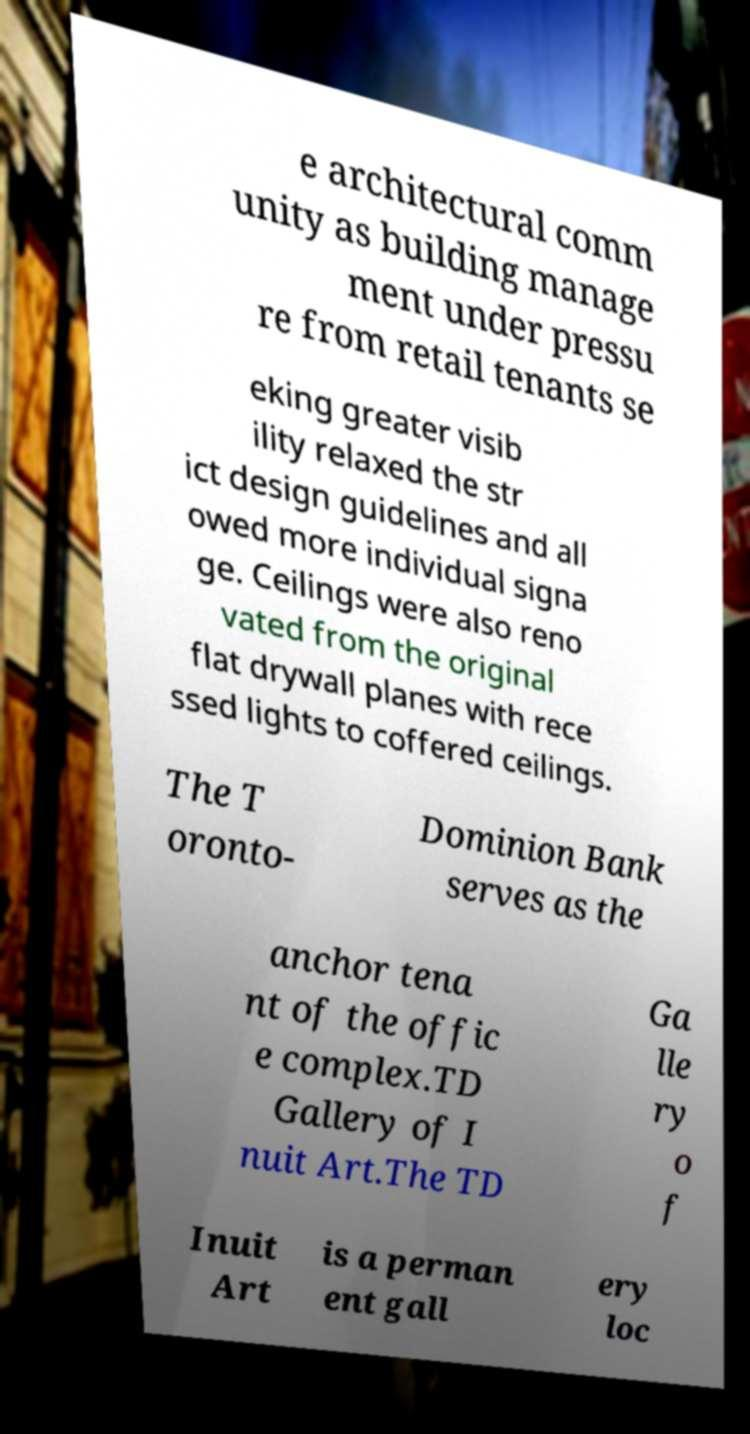I need the written content from this picture converted into text. Can you do that? e architectural comm unity as building manage ment under pressu re from retail tenants se eking greater visib ility relaxed the str ict design guidelines and all owed more individual signa ge. Ceilings were also reno vated from the original flat drywall planes with rece ssed lights to coffered ceilings. The T oronto- Dominion Bank serves as the anchor tena nt of the offic e complex.TD Gallery of I nuit Art.The TD Ga lle ry o f Inuit Art is a perman ent gall ery loc 